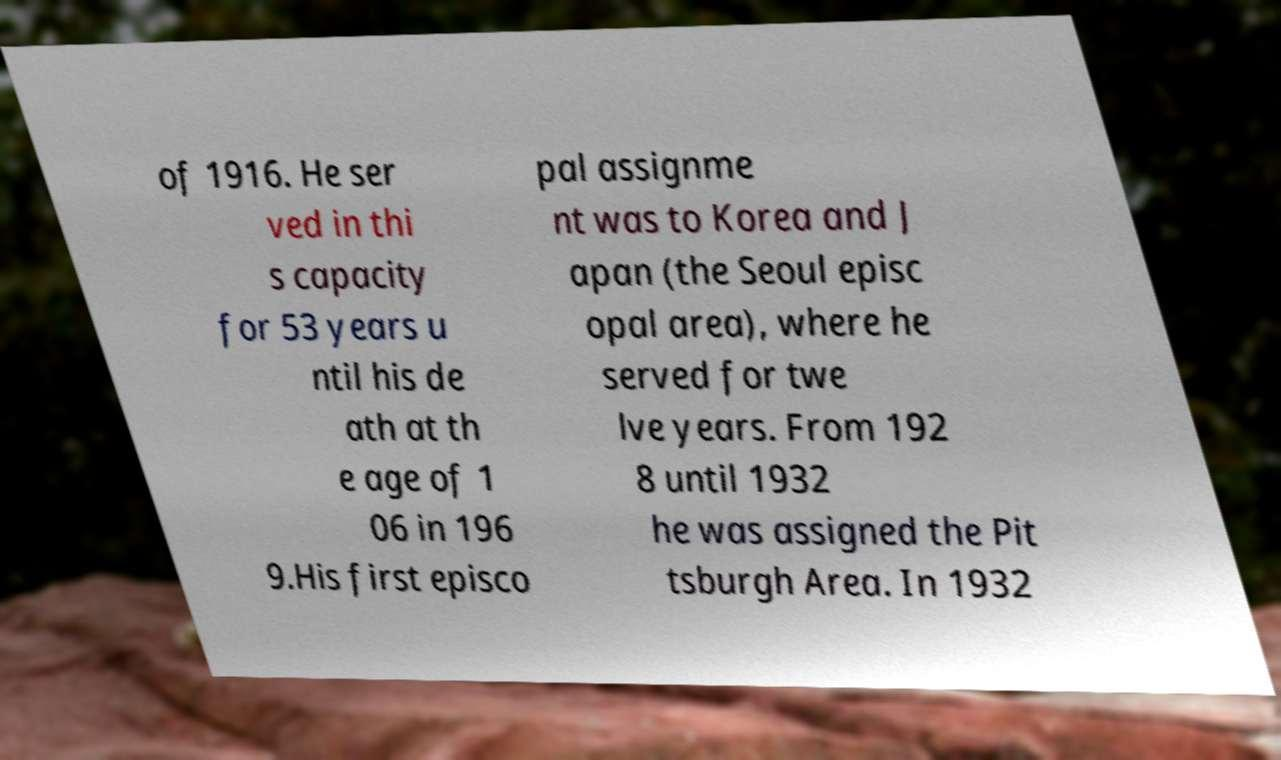Could you extract and type out the text from this image? of 1916. He ser ved in thi s capacity for 53 years u ntil his de ath at th e age of 1 06 in 196 9.His first episco pal assignme nt was to Korea and J apan (the Seoul episc opal area), where he served for twe lve years. From 192 8 until 1932 he was assigned the Pit tsburgh Area. In 1932 